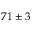Convert formula to latex. <formula><loc_0><loc_0><loc_500><loc_500>- 7 1 \pm 3</formula> 